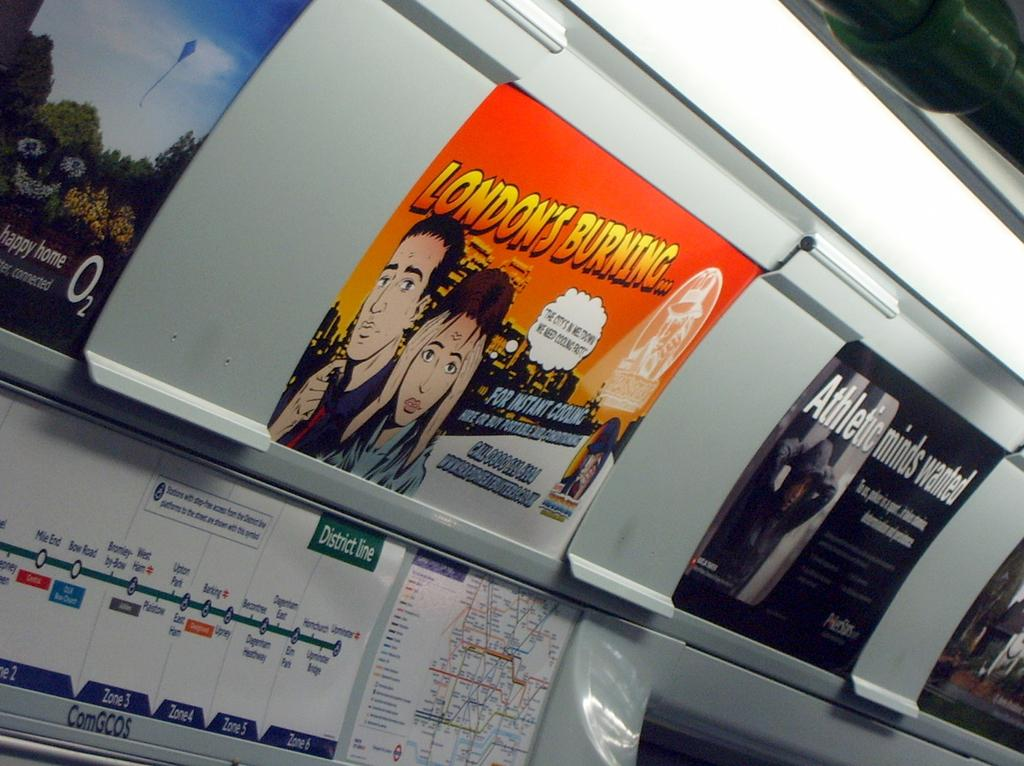<image>
Describe the image concisely. Advertisements on public transportation and one says London's Burning. 